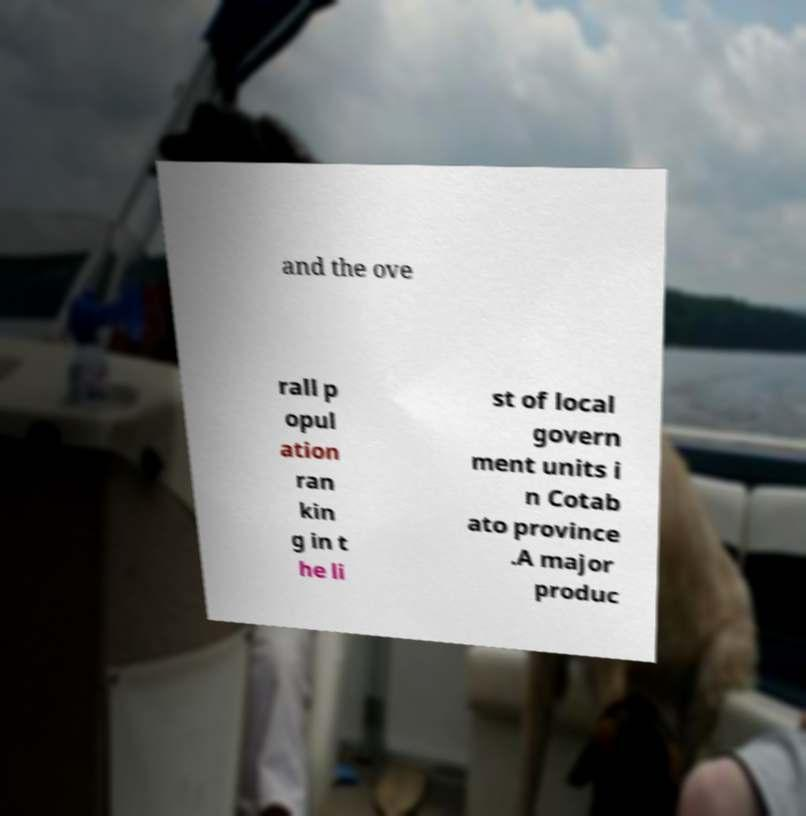I need the written content from this picture converted into text. Can you do that? and the ove rall p opul ation ran kin g in t he li st of local govern ment units i n Cotab ato province .A major produc 